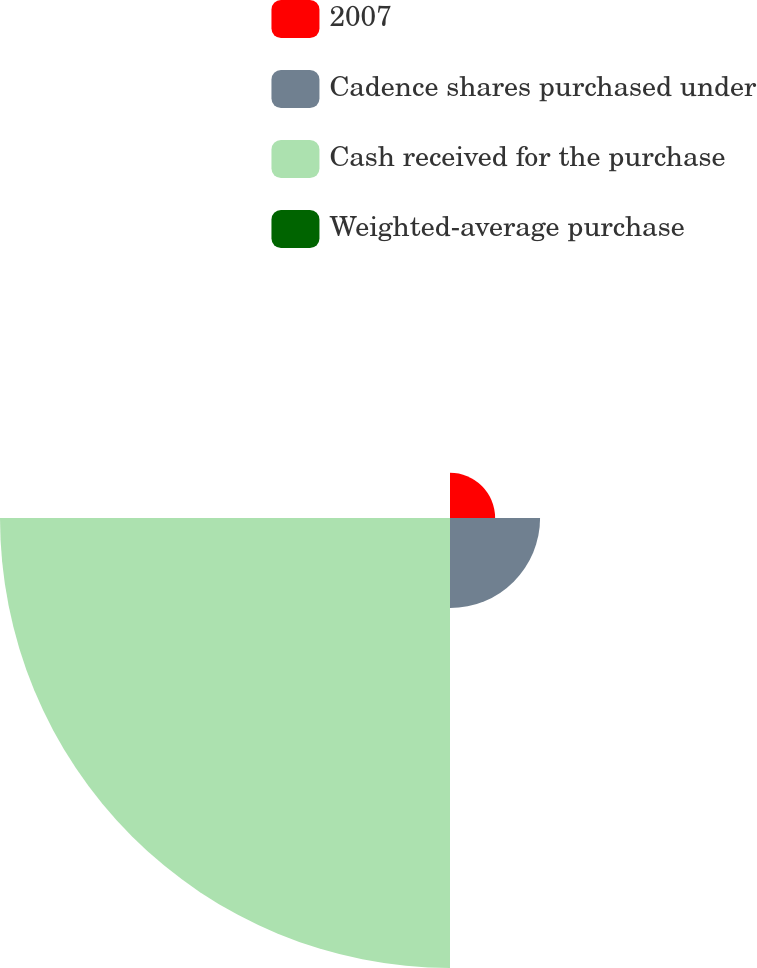Convert chart. <chart><loc_0><loc_0><loc_500><loc_500><pie_chart><fcel>2007<fcel>Cadence shares purchased under<fcel>Cash received for the purchase<fcel>Weighted-average purchase<nl><fcel>7.71%<fcel>15.39%<fcel>76.88%<fcel>0.02%<nl></chart> 